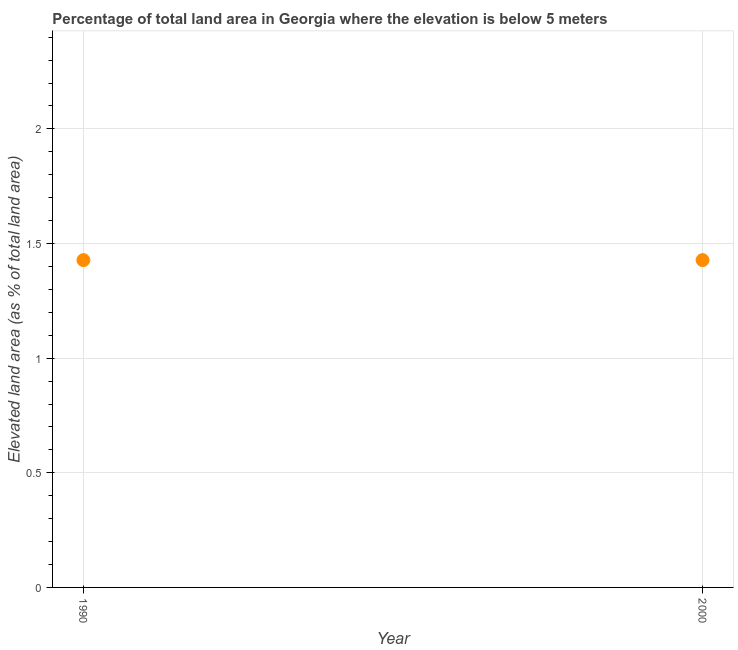What is the total elevated land area in 1990?
Give a very brief answer. 1.43. Across all years, what is the maximum total elevated land area?
Your response must be concise. 1.43. Across all years, what is the minimum total elevated land area?
Your answer should be very brief. 1.43. In which year was the total elevated land area maximum?
Provide a short and direct response. 1990. In which year was the total elevated land area minimum?
Keep it short and to the point. 1990. What is the sum of the total elevated land area?
Make the answer very short. 2.86. What is the average total elevated land area per year?
Offer a very short reply. 1.43. What is the median total elevated land area?
Keep it short and to the point. 1.43. In how many years, is the total elevated land area greater than 0.4 %?
Your answer should be very brief. 2. Do a majority of the years between 2000 and 1990 (inclusive) have total elevated land area greater than 0.4 %?
Offer a very short reply. No. What is the ratio of the total elevated land area in 1990 to that in 2000?
Provide a short and direct response. 1. Does the graph contain grids?
Keep it short and to the point. Yes. What is the title of the graph?
Your response must be concise. Percentage of total land area in Georgia where the elevation is below 5 meters. What is the label or title of the X-axis?
Your answer should be very brief. Year. What is the label or title of the Y-axis?
Give a very brief answer. Elevated land area (as % of total land area). What is the Elevated land area (as % of total land area) in 1990?
Your answer should be very brief. 1.43. What is the Elevated land area (as % of total land area) in 2000?
Ensure brevity in your answer.  1.43. What is the difference between the Elevated land area (as % of total land area) in 1990 and 2000?
Make the answer very short. 0. What is the ratio of the Elevated land area (as % of total land area) in 1990 to that in 2000?
Ensure brevity in your answer.  1. 